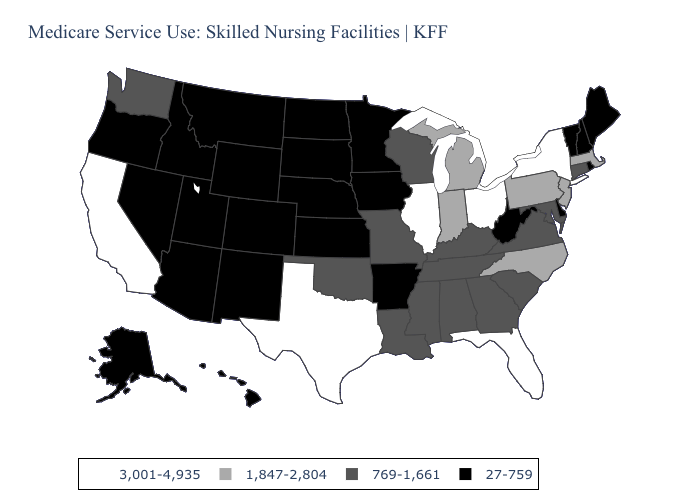Name the states that have a value in the range 1,847-2,804?
Answer briefly. Indiana, Massachusetts, Michigan, New Jersey, North Carolina, Pennsylvania. What is the value of Iowa?
Be succinct. 27-759. Name the states that have a value in the range 769-1,661?
Concise answer only. Alabama, Connecticut, Georgia, Kentucky, Louisiana, Maryland, Mississippi, Missouri, Oklahoma, South Carolina, Tennessee, Virginia, Washington, Wisconsin. What is the highest value in states that border Indiana?
Answer briefly. 3,001-4,935. What is the lowest value in the South?
Keep it brief. 27-759. Which states have the lowest value in the Northeast?
Short answer required. Maine, New Hampshire, Rhode Island, Vermont. Which states hav the highest value in the West?
Concise answer only. California. Name the states that have a value in the range 3,001-4,935?
Give a very brief answer. California, Florida, Illinois, New York, Ohio, Texas. What is the value of Nevada?
Be succinct. 27-759. Does New Hampshire have the lowest value in the Northeast?
Concise answer only. Yes. Name the states that have a value in the range 769-1,661?
Quick response, please. Alabama, Connecticut, Georgia, Kentucky, Louisiana, Maryland, Mississippi, Missouri, Oklahoma, South Carolina, Tennessee, Virginia, Washington, Wisconsin. Does the first symbol in the legend represent the smallest category?
Give a very brief answer. No. Does Connecticut have the same value as New York?
Quick response, please. No. Among the states that border Connecticut , which have the lowest value?
Quick response, please. Rhode Island. What is the highest value in the USA?
Write a very short answer. 3,001-4,935. 